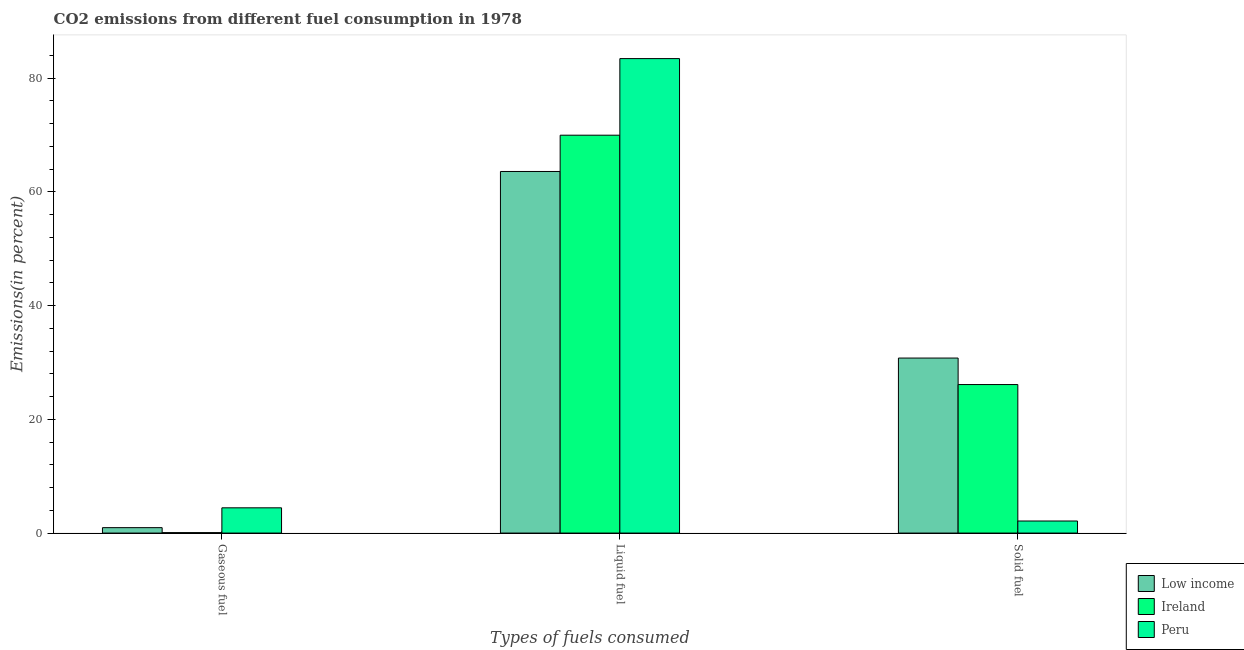How many groups of bars are there?
Offer a very short reply. 3. Are the number of bars per tick equal to the number of legend labels?
Ensure brevity in your answer.  Yes. How many bars are there on the 2nd tick from the right?
Your answer should be compact. 3. What is the label of the 1st group of bars from the left?
Your answer should be very brief. Gaseous fuel. What is the percentage of liquid fuel emission in Peru?
Give a very brief answer. 83.44. Across all countries, what is the maximum percentage of solid fuel emission?
Your answer should be very brief. 30.78. Across all countries, what is the minimum percentage of gaseous fuel emission?
Ensure brevity in your answer.  0.08. In which country was the percentage of gaseous fuel emission minimum?
Make the answer very short. Ireland. What is the total percentage of solid fuel emission in the graph?
Keep it short and to the point. 59.02. What is the difference between the percentage of solid fuel emission in Low income and that in Ireland?
Provide a succinct answer. 4.66. What is the difference between the percentage of gaseous fuel emission in Peru and the percentage of liquid fuel emission in Ireland?
Offer a very short reply. -65.53. What is the average percentage of solid fuel emission per country?
Your answer should be very brief. 19.67. What is the difference between the percentage of liquid fuel emission and percentage of solid fuel emission in Peru?
Offer a very short reply. 81.32. What is the ratio of the percentage of liquid fuel emission in Ireland to that in Low income?
Ensure brevity in your answer.  1.1. Is the percentage of gaseous fuel emission in Peru less than that in Ireland?
Give a very brief answer. No. Is the difference between the percentage of solid fuel emission in Ireland and Low income greater than the difference between the percentage of liquid fuel emission in Ireland and Low income?
Offer a terse response. No. What is the difference between the highest and the second highest percentage of gaseous fuel emission?
Offer a very short reply. 3.49. What is the difference between the highest and the lowest percentage of solid fuel emission?
Provide a short and direct response. 28.66. What does the 3rd bar from the left in Liquid fuel represents?
Offer a terse response. Peru. What does the 2nd bar from the right in Solid fuel represents?
Make the answer very short. Ireland. Is it the case that in every country, the sum of the percentage of gaseous fuel emission and percentage of liquid fuel emission is greater than the percentage of solid fuel emission?
Ensure brevity in your answer.  Yes. How many bars are there?
Provide a short and direct response. 9. Are all the bars in the graph horizontal?
Offer a terse response. No. What is the difference between two consecutive major ticks on the Y-axis?
Provide a short and direct response. 20. Are the values on the major ticks of Y-axis written in scientific E-notation?
Ensure brevity in your answer.  No. How many legend labels are there?
Your response must be concise. 3. How are the legend labels stacked?
Give a very brief answer. Vertical. What is the title of the graph?
Give a very brief answer. CO2 emissions from different fuel consumption in 1978. Does "Iceland" appear as one of the legend labels in the graph?
Your response must be concise. No. What is the label or title of the X-axis?
Offer a terse response. Types of fuels consumed. What is the label or title of the Y-axis?
Give a very brief answer. Emissions(in percent). What is the Emissions(in percent) in Low income in Gaseous fuel?
Offer a very short reply. 0.95. What is the Emissions(in percent) in Ireland in Gaseous fuel?
Keep it short and to the point. 0.08. What is the Emissions(in percent) in Peru in Gaseous fuel?
Your answer should be compact. 4.44. What is the Emissions(in percent) in Low income in Liquid fuel?
Offer a terse response. 63.59. What is the Emissions(in percent) of Ireland in Liquid fuel?
Your answer should be compact. 69.98. What is the Emissions(in percent) of Peru in Liquid fuel?
Keep it short and to the point. 83.44. What is the Emissions(in percent) of Low income in Solid fuel?
Offer a very short reply. 30.78. What is the Emissions(in percent) in Ireland in Solid fuel?
Offer a terse response. 26.12. What is the Emissions(in percent) in Peru in Solid fuel?
Provide a short and direct response. 2.12. Across all Types of fuels consumed, what is the maximum Emissions(in percent) of Low income?
Keep it short and to the point. 63.59. Across all Types of fuels consumed, what is the maximum Emissions(in percent) of Ireland?
Keep it short and to the point. 69.98. Across all Types of fuels consumed, what is the maximum Emissions(in percent) in Peru?
Offer a very short reply. 83.44. Across all Types of fuels consumed, what is the minimum Emissions(in percent) of Low income?
Keep it short and to the point. 0.95. Across all Types of fuels consumed, what is the minimum Emissions(in percent) in Ireland?
Your answer should be very brief. 0.08. Across all Types of fuels consumed, what is the minimum Emissions(in percent) in Peru?
Ensure brevity in your answer.  2.12. What is the total Emissions(in percent) in Low income in the graph?
Offer a terse response. 95.33. What is the total Emissions(in percent) of Ireland in the graph?
Make the answer very short. 96.17. What is the total Emissions(in percent) of Peru in the graph?
Provide a succinct answer. 90.01. What is the difference between the Emissions(in percent) of Low income in Gaseous fuel and that in Liquid fuel?
Your response must be concise. -62.64. What is the difference between the Emissions(in percent) in Ireland in Gaseous fuel and that in Liquid fuel?
Offer a terse response. -69.9. What is the difference between the Emissions(in percent) in Peru in Gaseous fuel and that in Liquid fuel?
Your answer should be compact. -79. What is the difference between the Emissions(in percent) of Low income in Gaseous fuel and that in Solid fuel?
Your answer should be compact. -29.83. What is the difference between the Emissions(in percent) of Ireland in Gaseous fuel and that in Solid fuel?
Provide a short and direct response. -26.04. What is the difference between the Emissions(in percent) in Peru in Gaseous fuel and that in Solid fuel?
Provide a succinct answer. 2.32. What is the difference between the Emissions(in percent) of Low income in Liquid fuel and that in Solid fuel?
Make the answer very short. 32.81. What is the difference between the Emissions(in percent) of Ireland in Liquid fuel and that in Solid fuel?
Offer a terse response. 43.85. What is the difference between the Emissions(in percent) of Peru in Liquid fuel and that in Solid fuel?
Ensure brevity in your answer.  81.32. What is the difference between the Emissions(in percent) in Low income in Gaseous fuel and the Emissions(in percent) in Ireland in Liquid fuel?
Your response must be concise. -69.02. What is the difference between the Emissions(in percent) in Low income in Gaseous fuel and the Emissions(in percent) in Peru in Liquid fuel?
Provide a succinct answer. -82.49. What is the difference between the Emissions(in percent) of Ireland in Gaseous fuel and the Emissions(in percent) of Peru in Liquid fuel?
Your response must be concise. -83.37. What is the difference between the Emissions(in percent) of Low income in Gaseous fuel and the Emissions(in percent) of Ireland in Solid fuel?
Offer a very short reply. -25.17. What is the difference between the Emissions(in percent) of Low income in Gaseous fuel and the Emissions(in percent) of Peru in Solid fuel?
Make the answer very short. -1.17. What is the difference between the Emissions(in percent) of Ireland in Gaseous fuel and the Emissions(in percent) of Peru in Solid fuel?
Give a very brief answer. -2.04. What is the difference between the Emissions(in percent) in Low income in Liquid fuel and the Emissions(in percent) in Ireland in Solid fuel?
Your response must be concise. 37.47. What is the difference between the Emissions(in percent) of Low income in Liquid fuel and the Emissions(in percent) of Peru in Solid fuel?
Provide a succinct answer. 61.47. What is the difference between the Emissions(in percent) in Ireland in Liquid fuel and the Emissions(in percent) in Peru in Solid fuel?
Make the answer very short. 67.85. What is the average Emissions(in percent) of Low income per Types of fuels consumed?
Your answer should be compact. 31.78. What is the average Emissions(in percent) of Ireland per Types of fuels consumed?
Keep it short and to the point. 32.06. What is the average Emissions(in percent) in Peru per Types of fuels consumed?
Give a very brief answer. 30. What is the difference between the Emissions(in percent) in Low income and Emissions(in percent) in Ireland in Gaseous fuel?
Offer a terse response. 0.88. What is the difference between the Emissions(in percent) of Low income and Emissions(in percent) of Peru in Gaseous fuel?
Keep it short and to the point. -3.49. What is the difference between the Emissions(in percent) in Ireland and Emissions(in percent) in Peru in Gaseous fuel?
Give a very brief answer. -4.36. What is the difference between the Emissions(in percent) in Low income and Emissions(in percent) in Ireland in Liquid fuel?
Make the answer very short. -6.38. What is the difference between the Emissions(in percent) of Low income and Emissions(in percent) of Peru in Liquid fuel?
Keep it short and to the point. -19.85. What is the difference between the Emissions(in percent) in Ireland and Emissions(in percent) in Peru in Liquid fuel?
Keep it short and to the point. -13.47. What is the difference between the Emissions(in percent) of Low income and Emissions(in percent) of Ireland in Solid fuel?
Offer a very short reply. 4.66. What is the difference between the Emissions(in percent) of Low income and Emissions(in percent) of Peru in Solid fuel?
Offer a terse response. 28.66. What is the difference between the Emissions(in percent) of Ireland and Emissions(in percent) of Peru in Solid fuel?
Your response must be concise. 24. What is the ratio of the Emissions(in percent) of Low income in Gaseous fuel to that in Liquid fuel?
Give a very brief answer. 0.01. What is the ratio of the Emissions(in percent) of Ireland in Gaseous fuel to that in Liquid fuel?
Give a very brief answer. 0. What is the ratio of the Emissions(in percent) of Peru in Gaseous fuel to that in Liquid fuel?
Provide a short and direct response. 0.05. What is the ratio of the Emissions(in percent) in Low income in Gaseous fuel to that in Solid fuel?
Offer a terse response. 0.03. What is the ratio of the Emissions(in percent) of Ireland in Gaseous fuel to that in Solid fuel?
Make the answer very short. 0. What is the ratio of the Emissions(in percent) of Peru in Gaseous fuel to that in Solid fuel?
Your answer should be very brief. 2.09. What is the ratio of the Emissions(in percent) in Low income in Liquid fuel to that in Solid fuel?
Give a very brief answer. 2.07. What is the ratio of the Emissions(in percent) in Ireland in Liquid fuel to that in Solid fuel?
Your answer should be very brief. 2.68. What is the ratio of the Emissions(in percent) of Peru in Liquid fuel to that in Solid fuel?
Provide a succinct answer. 39.32. What is the difference between the highest and the second highest Emissions(in percent) in Low income?
Make the answer very short. 32.81. What is the difference between the highest and the second highest Emissions(in percent) of Ireland?
Ensure brevity in your answer.  43.85. What is the difference between the highest and the second highest Emissions(in percent) in Peru?
Offer a terse response. 79. What is the difference between the highest and the lowest Emissions(in percent) in Low income?
Your answer should be compact. 62.64. What is the difference between the highest and the lowest Emissions(in percent) in Ireland?
Provide a succinct answer. 69.9. What is the difference between the highest and the lowest Emissions(in percent) of Peru?
Give a very brief answer. 81.32. 